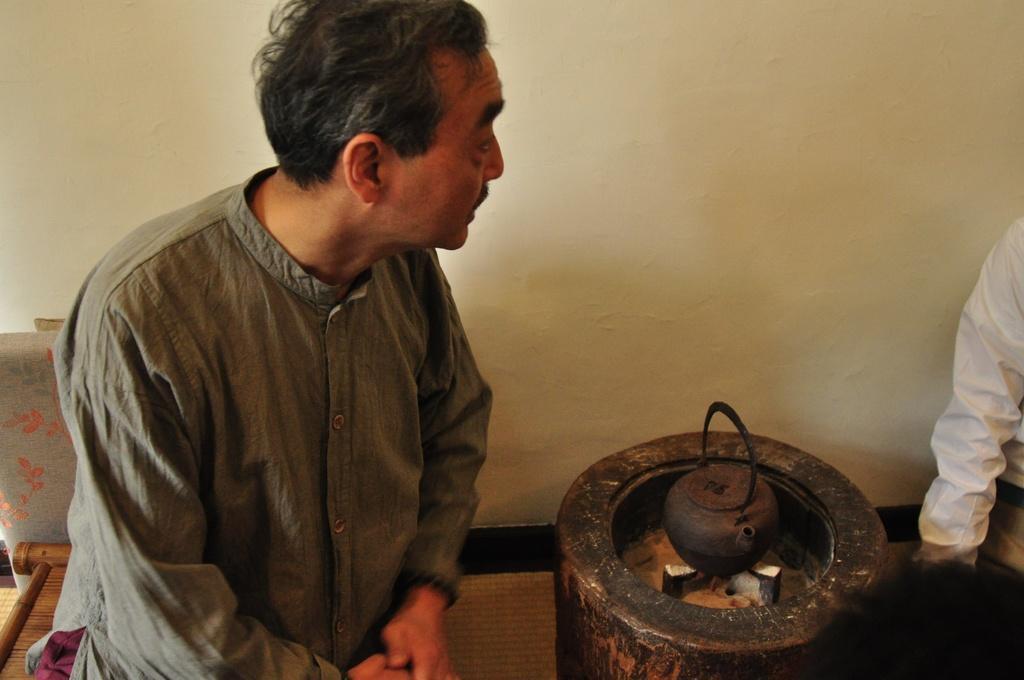Could you give a brief overview of what you see in this image? In this image there is a man on the left side who is siting on the chair. Beside him there is a wooden stove on which there is a kettle. In the background there is a wall. On the right side there is another person. 